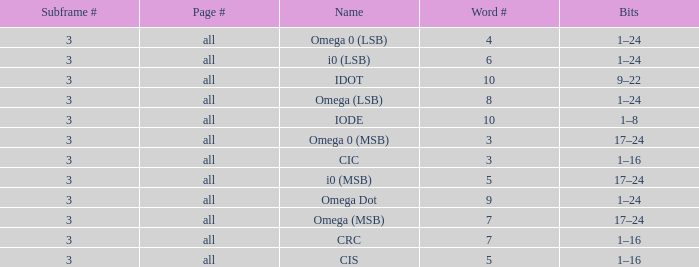What is the word count that is named omega dot? 9.0. Parse the full table. {'header': ['Subframe #', 'Page #', 'Name', 'Word #', 'Bits'], 'rows': [['3', 'all', 'Omega 0 (LSB)', '4', '1–24'], ['3', 'all', 'i0 (LSB)', '6', '1–24'], ['3', 'all', 'IDOT', '10', '9–22'], ['3', 'all', 'Omega (LSB)', '8', '1–24'], ['3', 'all', 'IODE', '10', '1–8'], ['3', 'all', 'Omega 0 (MSB)', '3', '17–24'], ['3', 'all', 'CIC', '3', '1–16'], ['3', 'all', 'i0 (MSB)', '5', '17–24'], ['3', 'all', 'Omega Dot', '9', '1–24'], ['3', 'all', 'Omega (MSB)', '7', '17–24'], ['3', 'all', 'CRC', '7', '1–16'], ['3', 'all', 'CIS', '5', '1–16']]} 